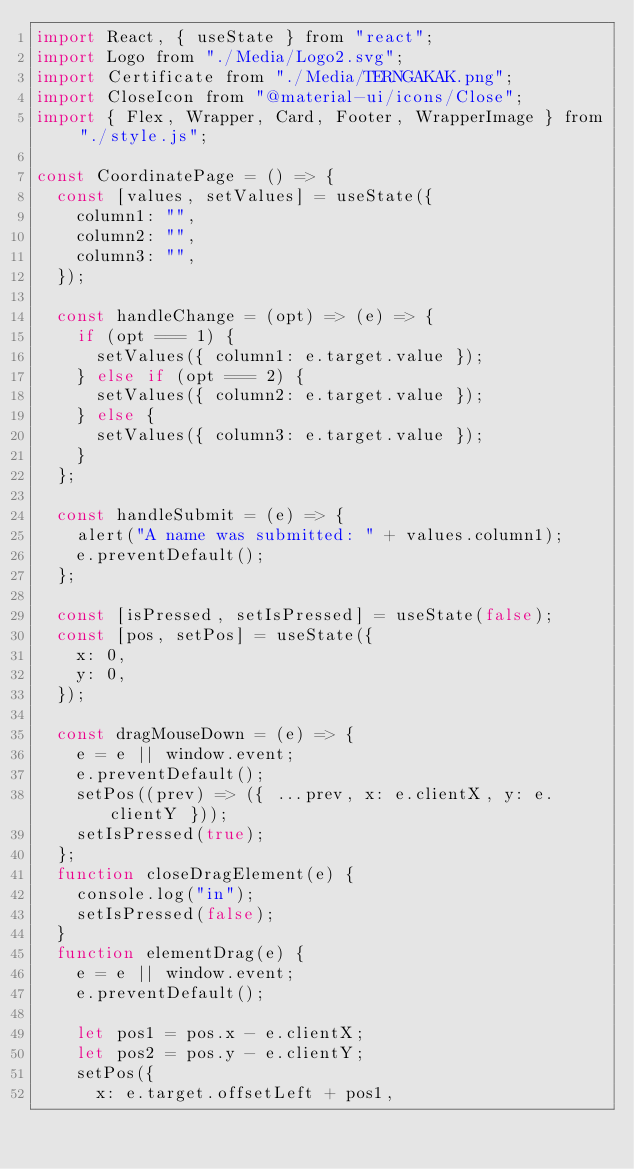<code> <loc_0><loc_0><loc_500><loc_500><_JavaScript_>import React, { useState } from "react";
import Logo from "./Media/Logo2.svg";
import Certificate from "./Media/TERNGAKAK.png";
import CloseIcon from "@material-ui/icons/Close";
import { Flex, Wrapper, Card, Footer, WrapperImage } from "./style.js";

const CoordinatePage = () => {
  const [values, setValues] = useState({
    column1: "",
    column2: "",
    column3: "",
  });

  const handleChange = (opt) => (e) => {
    if (opt === 1) {
      setValues({ column1: e.target.value });
    } else if (opt === 2) {
      setValues({ column2: e.target.value });
    } else {
      setValues({ column3: e.target.value });
    }
  };

  const handleSubmit = (e) => {
    alert("A name was submitted: " + values.column1);
    e.preventDefault();
  };

  const [isPressed, setIsPressed] = useState(false);
  const [pos, setPos] = useState({
    x: 0,
    y: 0,
  });

  const dragMouseDown = (e) => {
    e = e || window.event;
    e.preventDefault();
    setPos((prev) => ({ ...prev, x: e.clientX, y: e.clientY }));
    setIsPressed(true);
  };
  function closeDragElement(e) {
    console.log("in");
    setIsPressed(false);
  }
  function elementDrag(e) {
    e = e || window.event;
    e.preventDefault();

    let pos1 = pos.x - e.clientX;
    let pos2 = pos.y - e.clientY;
    setPos({
      x: e.target.offsetLeft + pos1,</code> 